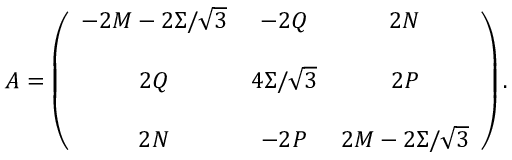Convert formula to latex. <formula><loc_0><loc_0><loc_500><loc_500>A = \left ( \begin{array} { c c c } { { - 2 M - 2 \Sigma / \sqrt { 3 } } } & { - 2 Q } & { 2 N } \\ { 2 Q } & { { 4 \Sigma / \sqrt { 3 } } } & { 2 P } \\ { 2 N } & { - 2 P } & { { 2 M - 2 \Sigma / \sqrt { 3 } } } \end{array} \right ) .</formula> 